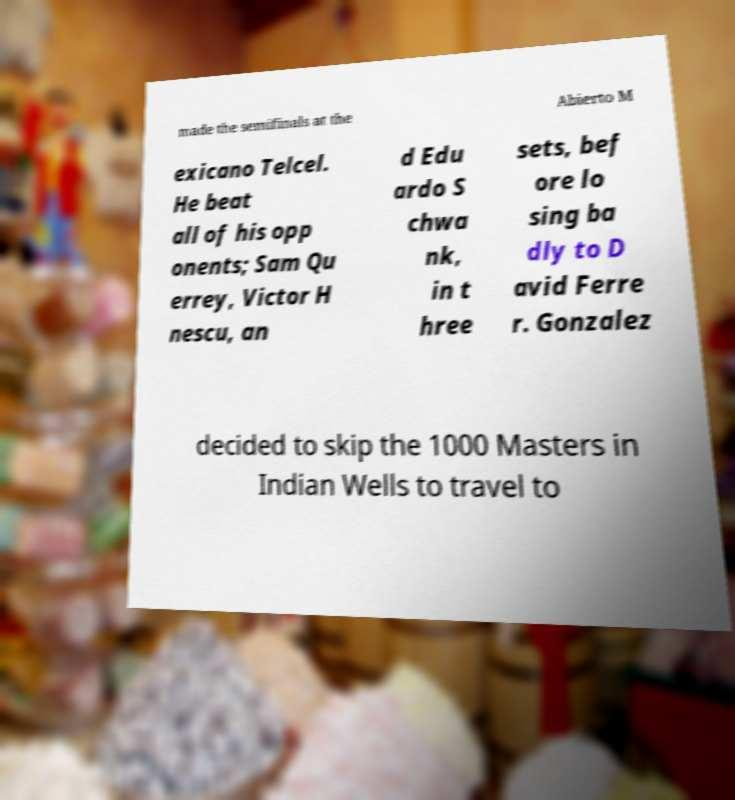What messages or text are displayed in this image? I need them in a readable, typed format. made the semifinals at the Abierto M exicano Telcel. He beat all of his opp onents; Sam Qu errey, Victor H nescu, an d Edu ardo S chwa nk, in t hree sets, bef ore lo sing ba dly to D avid Ferre r. Gonzalez decided to skip the 1000 Masters in Indian Wells to travel to 